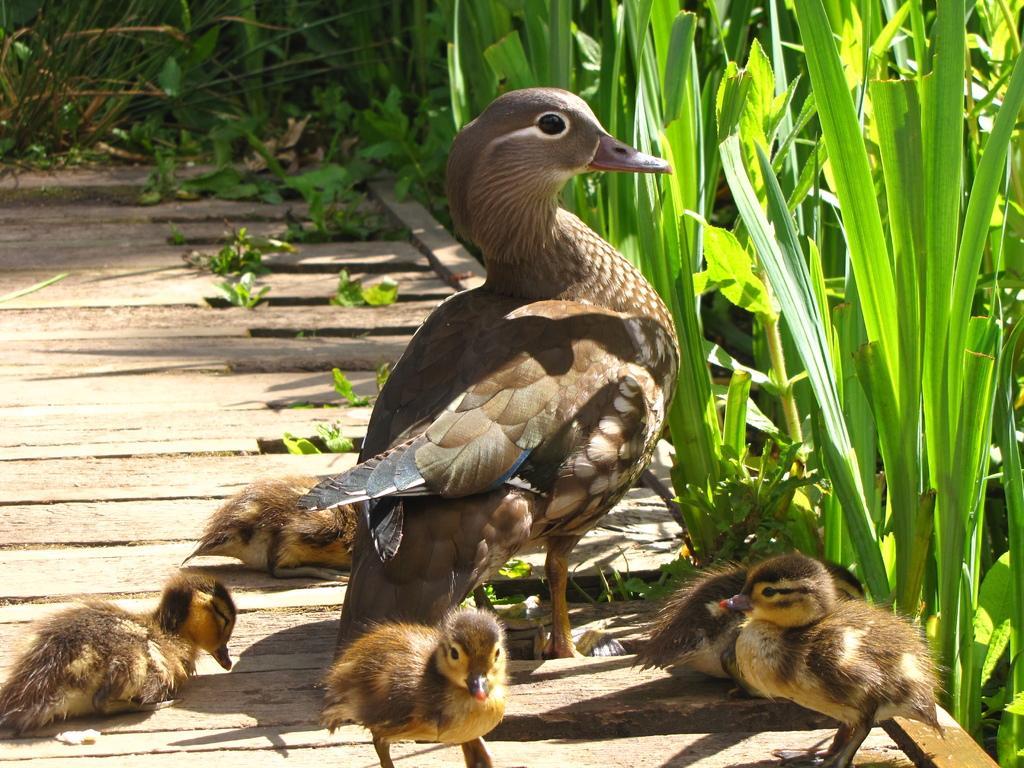Could you give a brief overview of what you see in this image? This picture is clicked outside the city. On the right there is a bird standing on the plank and we can see the chicks sitting on the plank and in the foreground there are two chicks standing on the plank. In the background we can see the plants and the wooden planks. 